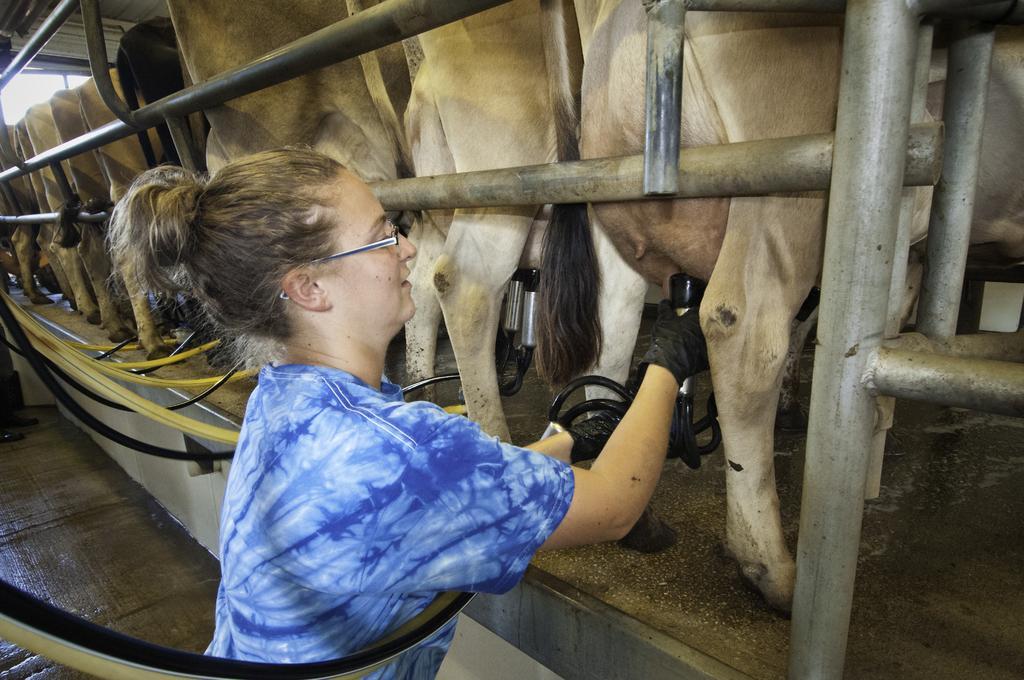Describe this image in one or two sentences. In the foreground of the picture there is a woman standing wearing a blue t-shirt, she is attaching pipes to the cow for milking. In the background there are cows and railing. On the left there are pipes. 